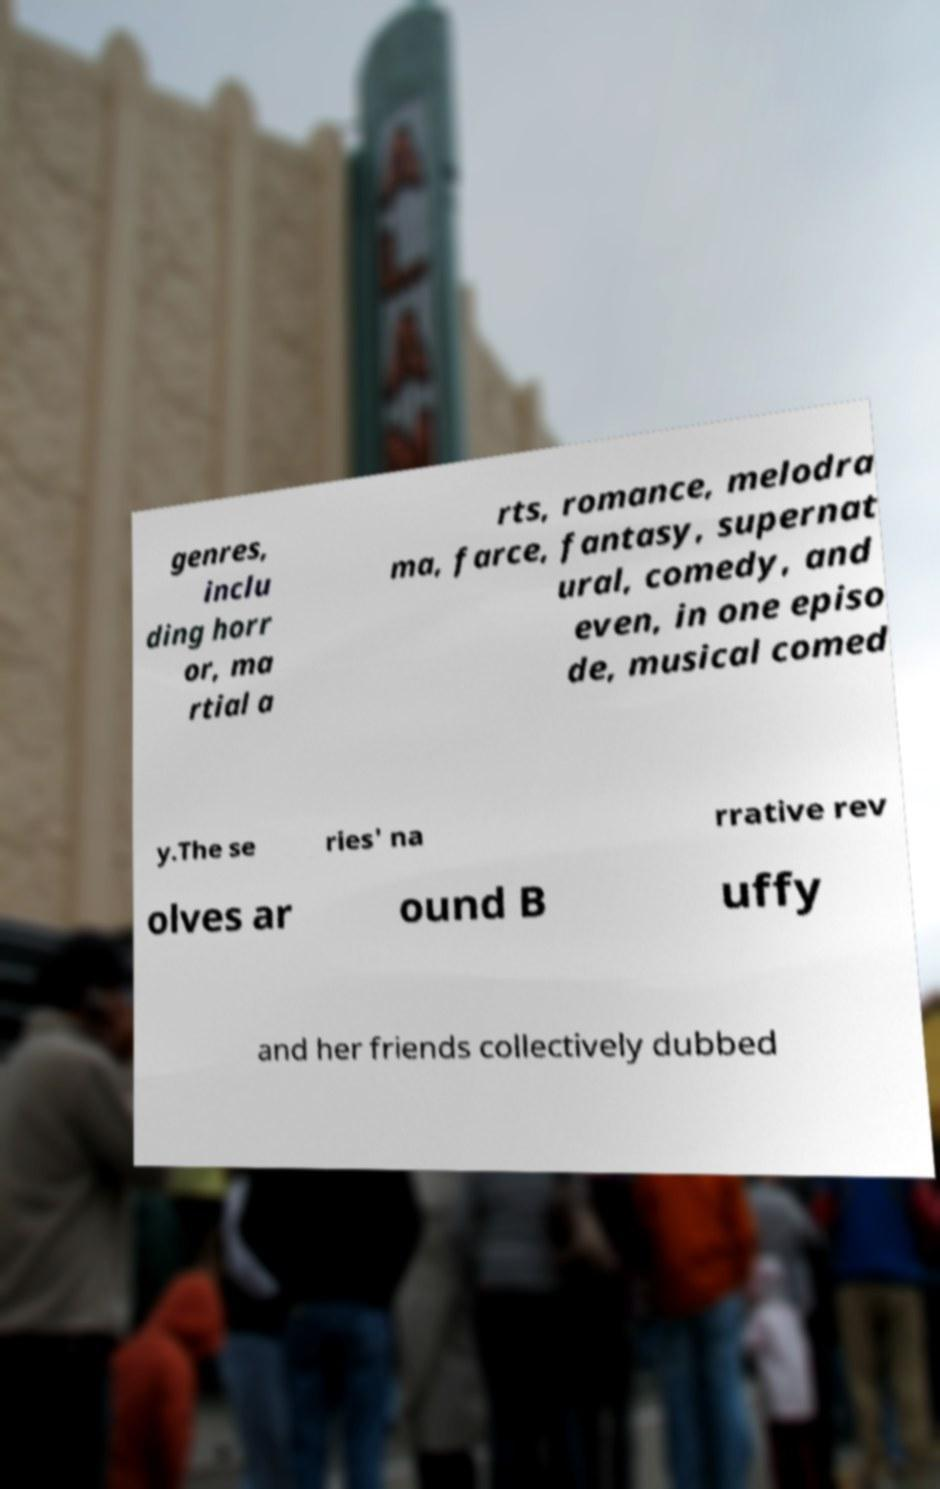For documentation purposes, I need the text within this image transcribed. Could you provide that? genres, inclu ding horr or, ma rtial a rts, romance, melodra ma, farce, fantasy, supernat ural, comedy, and even, in one episo de, musical comed y.The se ries' na rrative rev olves ar ound B uffy and her friends collectively dubbed 